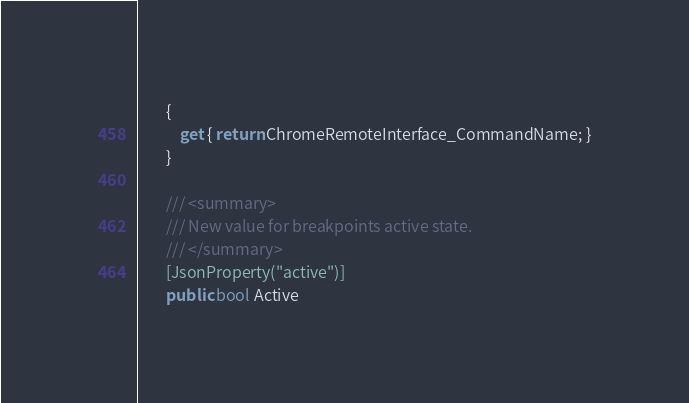Convert code to text. <code><loc_0><loc_0><loc_500><loc_500><_C#_>        {
            get { return ChromeRemoteInterface_CommandName; }
        }

        /// <summary>
        /// New value for breakpoints active state.
        /// </summary>
        [JsonProperty("active")]
        public bool Active</code> 